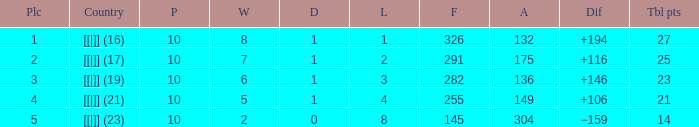 How many games had a deficit of 175?  1.0. 